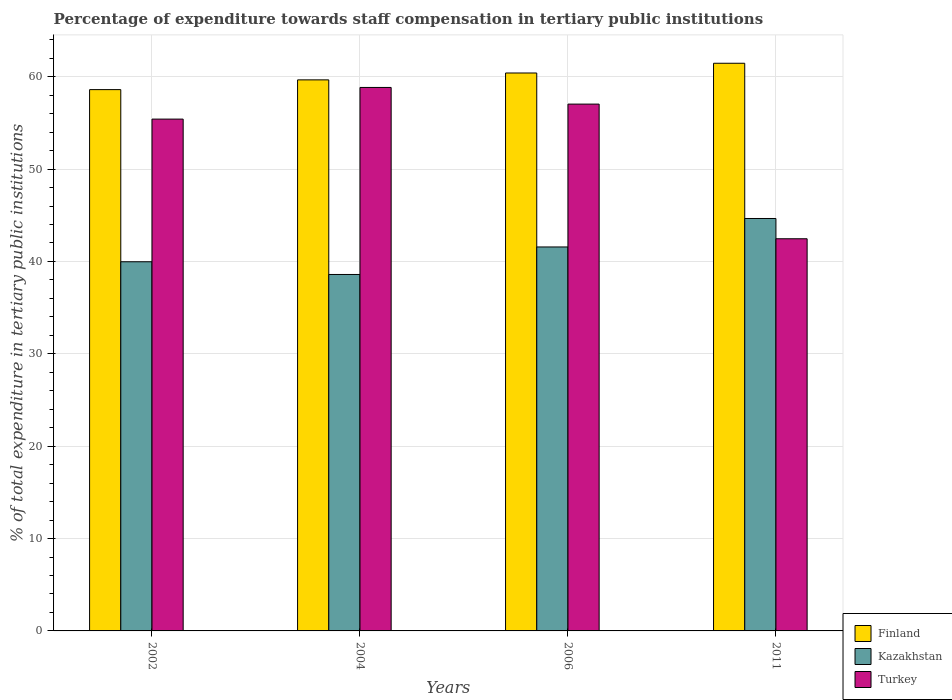Are the number of bars per tick equal to the number of legend labels?
Ensure brevity in your answer.  Yes. Are the number of bars on each tick of the X-axis equal?
Your answer should be compact. Yes. How many bars are there on the 2nd tick from the left?
Make the answer very short. 3. What is the label of the 1st group of bars from the left?
Ensure brevity in your answer.  2002. In how many cases, is the number of bars for a given year not equal to the number of legend labels?
Give a very brief answer. 0. What is the percentage of expenditure towards staff compensation in Finland in 2004?
Ensure brevity in your answer.  59.66. Across all years, what is the maximum percentage of expenditure towards staff compensation in Turkey?
Provide a short and direct response. 58.84. Across all years, what is the minimum percentage of expenditure towards staff compensation in Turkey?
Your answer should be compact. 42.45. In which year was the percentage of expenditure towards staff compensation in Finland maximum?
Your response must be concise. 2011. What is the total percentage of expenditure towards staff compensation in Finland in the graph?
Give a very brief answer. 240.11. What is the difference between the percentage of expenditure towards staff compensation in Turkey in 2002 and that in 2004?
Your answer should be very brief. -3.43. What is the difference between the percentage of expenditure towards staff compensation in Turkey in 2011 and the percentage of expenditure towards staff compensation in Finland in 2002?
Provide a succinct answer. -16.15. What is the average percentage of expenditure towards staff compensation in Kazakhstan per year?
Your answer should be very brief. 41.19. In the year 2002, what is the difference between the percentage of expenditure towards staff compensation in Kazakhstan and percentage of expenditure towards staff compensation in Turkey?
Offer a very short reply. -15.44. What is the ratio of the percentage of expenditure towards staff compensation in Finland in 2002 to that in 2004?
Keep it short and to the point. 0.98. Is the percentage of expenditure towards staff compensation in Turkey in 2002 less than that in 2004?
Give a very brief answer. Yes. Is the difference between the percentage of expenditure towards staff compensation in Kazakhstan in 2004 and 2011 greater than the difference between the percentage of expenditure towards staff compensation in Turkey in 2004 and 2011?
Provide a succinct answer. No. What is the difference between the highest and the second highest percentage of expenditure towards staff compensation in Finland?
Offer a terse response. 1.05. What is the difference between the highest and the lowest percentage of expenditure towards staff compensation in Kazakhstan?
Your response must be concise. 6.06. In how many years, is the percentage of expenditure towards staff compensation in Turkey greater than the average percentage of expenditure towards staff compensation in Turkey taken over all years?
Your answer should be compact. 3. Is the sum of the percentage of expenditure towards staff compensation in Turkey in 2006 and 2011 greater than the maximum percentage of expenditure towards staff compensation in Finland across all years?
Ensure brevity in your answer.  Yes. What does the 2nd bar from the left in 2011 represents?
Offer a very short reply. Kazakhstan. What does the 3rd bar from the right in 2002 represents?
Your answer should be compact. Finland. Are the values on the major ticks of Y-axis written in scientific E-notation?
Keep it short and to the point. No. Does the graph contain any zero values?
Ensure brevity in your answer.  No. Where does the legend appear in the graph?
Keep it short and to the point. Bottom right. How are the legend labels stacked?
Give a very brief answer. Vertical. What is the title of the graph?
Provide a succinct answer. Percentage of expenditure towards staff compensation in tertiary public institutions. Does "United States" appear as one of the legend labels in the graph?
Provide a succinct answer. No. What is the label or title of the Y-axis?
Keep it short and to the point. % of total expenditure in tertiary public institutions. What is the % of total expenditure in tertiary public institutions of Finland in 2002?
Your response must be concise. 58.6. What is the % of total expenditure in tertiary public institutions in Kazakhstan in 2002?
Ensure brevity in your answer.  39.97. What is the % of total expenditure in tertiary public institutions in Turkey in 2002?
Give a very brief answer. 55.41. What is the % of total expenditure in tertiary public institutions in Finland in 2004?
Your answer should be compact. 59.66. What is the % of total expenditure in tertiary public institutions of Kazakhstan in 2004?
Your response must be concise. 38.59. What is the % of total expenditure in tertiary public institutions of Turkey in 2004?
Provide a succinct answer. 58.84. What is the % of total expenditure in tertiary public institutions in Finland in 2006?
Your answer should be very brief. 60.4. What is the % of total expenditure in tertiary public institutions in Kazakhstan in 2006?
Provide a short and direct response. 41.57. What is the % of total expenditure in tertiary public institutions of Turkey in 2006?
Ensure brevity in your answer.  57.03. What is the % of total expenditure in tertiary public institutions of Finland in 2011?
Keep it short and to the point. 61.45. What is the % of total expenditure in tertiary public institutions in Kazakhstan in 2011?
Your answer should be very brief. 44.65. What is the % of total expenditure in tertiary public institutions of Turkey in 2011?
Ensure brevity in your answer.  42.45. Across all years, what is the maximum % of total expenditure in tertiary public institutions of Finland?
Keep it short and to the point. 61.45. Across all years, what is the maximum % of total expenditure in tertiary public institutions in Kazakhstan?
Your response must be concise. 44.65. Across all years, what is the maximum % of total expenditure in tertiary public institutions of Turkey?
Keep it short and to the point. 58.84. Across all years, what is the minimum % of total expenditure in tertiary public institutions in Finland?
Make the answer very short. 58.6. Across all years, what is the minimum % of total expenditure in tertiary public institutions in Kazakhstan?
Provide a succinct answer. 38.59. Across all years, what is the minimum % of total expenditure in tertiary public institutions in Turkey?
Keep it short and to the point. 42.45. What is the total % of total expenditure in tertiary public institutions of Finland in the graph?
Ensure brevity in your answer.  240.11. What is the total % of total expenditure in tertiary public institutions of Kazakhstan in the graph?
Offer a very short reply. 164.77. What is the total % of total expenditure in tertiary public institutions of Turkey in the graph?
Offer a terse response. 213.73. What is the difference between the % of total expenditure in tertiary public institutions in Finland in 2002 and that in 2004?
Make the answer very short. -1.06. What is the difference between the % of total expenditure in tertiary public institutions of Kazakhstan in 2002 and that in 2004?
Your answer should be very brief. 1.38. What is the difference between the % of total expenditure in tertiary public institutions in Turkey in 2002 and that in 2004?
Your response must be concise. -3.43. What is the difference between the % of total expenditure in tertiary public institutions of Finland in 2002 and that in 2006?
Your answer should be compact. -1.8. What is the difference between the % of total expenditure in tertiary public institutions in Kazakhstan in 2002 and that in 2006?
Your response must be concise. -1.6. What is the difference between the % of total expenditure in tertiary public institutions of Turkey in 2002 and that in 2006?
Keep it short and to the point. -1.63. What is the difference between the % of total expenditure in tertiary public institutions in Finland in 2002 and that in 2011?
Your answer should be very brief. -2.85. What is the difference between the % of total expenditure in tertiary public institutions of Kazakhstan in 2002 and that in 2011?
Give a very brief answer. -4.68. What is the difference between the % of total expenditure in tertiary public institutions of Turkey in 2002 and that in 2011?
Offer a terse response. 12.95. What is the difference between the % of total expenditure in tertiary public institutions of Finland in 2004 and that in 2006?
Your response must be concise. -0.74. What is the difference between the % of total expenditure in tertiary public institutions of Kazakhstan in 2004 and that in 2006?
Offer a terse response. -2.98. What is the difference between the % of total expenditure in tertiary public institutions of Turkey in 2004 and that in 2006?
Offer a very short reply. 1.8. What is the difference between the % of total expenditure in tertiary public institutions of Finland in 2004 and that in 2011?
Your answer should be compact. -1.8. What is the difference between the % of total expenditure in tertiary public institutions in Kazakhstan in 2004 and that in 2011?
Provide a succinct answer. -6.06. What is the difference between the % of total expenditure in tertiary public institutions in Turkey in 2004 and that in 2011?
Provide a succinct answer. 16.38. What is the difference between the % of total expenditure in tertiary public institutions in Finland in 2006 and that in 2011?
Offer a terse response. -1.05. What is the difference between the % of total expenditure in tertiary public institutions in Kazakhstan in 2006 and that in 2011?
Your response must be concise. -3.08. What is the difference between the % of total expenditure in tertiary public institutions of Turkey in 2006 and that in 2011?
Your response must be concise. 14.58. What is the difference between the % of total expenditure in tertiary public institutions in Finland in 2002 and the % of total expenditure in tertiary public institutions in Kazakhstan in 2004?
Your answer should be very brief. 20.01. What is the difference between the % of total expenditure in tertiary public institutions of Finland in 2002 and the % of total expenditure in tertiary public institutions of Turkey in 2004?
Offer a very short reply. -0.23. What is the difference between the % of total expenditure in tertiary public institutions of Kazakhstan in 2002 and the % of total expenditure in tertiary public institutions of Turkey in 2004?
Offer a terse response. -18.87. What is the difference between the % of total expenditure in tertiary public institutions in Finland in 2002 and the % of total expenditure in tertiary public institutions in Kazakhstan in 2006?
Keep it short and to the point. 17.03. What is the difference between the % of total expenditure in tertiary public institutions of Finland in 2002 and the % of total expenditure in tertiary public institutions of Turkey in 2006?
Your response must be concise. 1.57. What is the difference between the % of total expenditure in tertiary public institutions of Kazakhstan in 2002 and the % of total expenditure in tertiary public institutions of Turkey in 2006?
Give a very brief answer. -17.07. What is the difference between the % of total expenditure in tertiary public institutions of Finland in 2002 and the % of total expenditure in tertiary public institutions of Kazakhstan in 2011?
Offer a very short reply. 13.95. What is the difference between the % of total expenditure in tertiary public institutions of Finland in 2002 and the % of total expenditure in tertiary public institutions of Turkey in 2011?
Offer a terse response. 16.15. What is the difference between the % of total expenditure in tertiary public institutions of Kazakhstan in 2002 and the % of total expenditure in tertiary public institutions of Turkey in 2011?
Your answer should be very brief. -2.49. What is the difference between the % of total expenditure in tertiary public institutions of Finland in 2004 and the % of total expenditure in tertiary public institutions of Kazakhstan in 2006?
Ensure brevity in your answer.  18.09. What is the difference between the % of total expenditure in tertiary public institutions in Finland in 2004 and the % of total expenditure in tertiary public institutions in Turkey in 2006?
Offer a very short reply. 2.62. What is the difference between the % of total expenditure in tertiary public institutions of Kazakhstan in 2004 and the % of total expenditure in tertiary public institutions of Turkey in 2006?
Your response must be concise. -18.44. What is the difference between the % of total expenditure in tertiary public institutions in Finland in 2004 and the % of total expenditure in tertiary public institutions in Kazakhstan in 2011?
Your response must be concise. 15.01. What is the difference between the % of total expenditure in tertiary public institutions in Finland in 2004 and the % of total expenditure in tertiary public institutions in Turkey in 2011?
Give a very brief answer. 17.2. What is the difference between the % of total expenditure in tertiary public institutions of Kazakhstan in 2004 and the % of total expenditure in tertiary public institutions of Turkey in 2011?
Give a very brief answer. -3.87. What is the difference between the % of total expenditure in tertiary public institutions of Finland in 2006 and the % of total expenditure in tertiary public institutions of Kazakhstan in 2011?
Keep it short and to the point. 15.75. What is the difference between the % of total expenditure in tertiary public institutions of Finland in 2006 and the % of total expenditure in tertiary public institutions of Turkey in 2011?
Provide a succinct answer. 17.95. What is the difference between the % of total expenditure in tertiary public institutions of Kazakhstan in 2006 and the % of total expenditure in tertiary public institutions of Turkey in 2011?
Offer a very short reply. -0.89. What is the average % of total expenditure in tertiary public institutions of Finland per year?
Give a very brief answer. 60.03. What is the average % of total expenditure in tertiary public institutions of Kazakhstan per year?
Ensure brevity in your answer.  41.19. What is the average % of total expenditure in tertiary public institutions in Turkey per year?
Keep it short and to the point. 53.43. In the year 2002, what is the difference between the % of total expenditure in tertiary public institutions of Finland and % of total expenditure in tertiary public institutions of Kazakhstan?
Provide a short and direct response. 18.64. In the year 2002, what is the difference between the % of total expenditure in tertiary public institutions of Finland and % of total expenditure in tertiary public institutions of Turkey?
Offer a very short reply. 3.19. In the year 2002, what is the difference between the % of total expenditure in tertiary public institutions in Kazakhstan and % of total expenditure in tertiary public institutions in Turkey?
Make the answer very short. -15.44. In the year 2004, what is the difference between the % of total expenditure in tertiary public institutions in Finland and % of total expenditure in tertiary public institutions in Kazakhstan?
Offer a very short reply. 21.07. In the year 2004, what is the difference between the % of total expenditure in tertiary public institutions of Finland and % of total expenditure in tertiary public institutions of Turkey?
Provide a succinct answer. 0.82. In the year 2004, what is the difference between the % of total expenditure in tertiary public institutions in Kazakhstan and % of total expenditure in tertiary public institutions in Turkey?
Your answer should be compact. -20.25. In the year 2006, what is the difference between the % of total expenditure in tertiary public institutions in Finland and % of total expenditure in tertiary public institutions in Kazakhstan?
Keep it short and to the point. 18.83. In the year 2006, what is the difference between the % of total expenditure in tertiary public institutions of Finland and % of total expenditure in tertiary public institutions of Turkey?
Offer a terse response. 3.37. In the year 2006, what is the difference between the % of total expenditure in tertiary public institutions of Kazakhstan and % of total expenditure in tertiary public institutions of Turkey?
Keep it short and to the point. -15.47. In the year 2011, what is the difference between the % of total expenditure in tertiary public institutions of Finland and % of total expenditure in tertiary public institutions of Kazakhstan?
Give a very brief answer. 16.81. In the year 2011, what is the difference between the % of total expenditure in tertiary public institutions of Finland and % of total expenditure in tertiary public institutions of Turkey?
Make the answer very short. 19. In the year 2011, what is the difference between the % of total expenditure in tertiary public institutions of Kazakhstan and % of total expenditure in tertiary public institutions of Turkey?
Ensure brevity in your answer.  2.19. What is the ratio of the % of total expenditure in tertiary public institutions in Finland in 2002 to that in 2004?
Provide a succinct answer. 0.98. What is the ratio of the % of total expenditure in tertiary public institutions in Kazakhstan in 2002 to that in 2004?
Your response must be concise. 1.04. What is the ratio of the % of total expenditure in tertiary public institutions in Turkey in 2002 to that in 2004?
Keep it short and to the point. 0.94. What is the ratio of the % of total expenditure in tertiary public institutions of Finland in 2002 to that in 2006?
Ensure brevity in your answer.  0.97. What is the ratio of the % of total expenditure in tertiary public institutions of Kazakhstan in 2002 to that in 2006?
Your answer should be very brief. 0.96. What is the ratio of the % of total expenditure in tertiary public institutions of Turkey in 2002 to that in 2006?
Offer a terse response. 0.97. What is the ratio of the % of total expenditure in tertiary public institutions in Finland in 2002 to that in 2011?
Provide a succinct answer. 0.95. What is the ratio of the % of total expenditure in tertiary public institutions of Kazakhstan in 2002 to that in 2011?
Your response must be concise. 0.9. What is the ratio of the % of total expenditure in tertiary public institutions of Turkey in 2002 to that in 2011?
Ensure brevity in your answer.  1.31. What is the ratio of the % of total expenditure in tertiary public institutions of Kazakhstan in 2004 to that in 2006?
Offer a very short reply. 0.93. What is the ratio of the % of total expenditure in tertiary public institutions in Turkey in 2004 to that in 2006?
Provide a succinct answer. 1.03. What is the ratio of the % of total expenditure in tertiary public institutions in Finland in 2004 to that in 2011?
Ensure brevity in your answer.  0.97. What is the ratio of the % of total expenditure in tertiary public institutions of Kazakhstan in 2004 to that in 2011?
Your answer should be very brief. 0.86. What is the ratio of the % of total expenditure in tertiary public institutions in Turkey in 2004 to that in 2011?
Give a very brief answer. 1.39. What is the ratio of the % of total expenditure in tertiary public institutions of Finland in 2006 to that in 2011?
Your answer should be compact. 0.98. What is the ratio of the % of total expenditure in tertiary public institutions of Turkey in 2006 to that in 2011?
Provide a succinct answer. 1.34. What is the difference between the highest and the second highest % of total expenditure in tertiary public institutions of Finland?
Your answer should be very brief. 1.05. What is the difference between the highest and the second highest % of total expenditure in tertiary public institutions in Kazakhstan?
Make the answer very short. 3.08. What is the difference between the highest and the second highest % of total expenditure in tertiary public institutions in Turkey?
Keep it short and to the point. 1.8. What is the difference between the highest and the lowest % of total expenditure in tertiary public institutions of Finland?
Your answer should be very brief. 2.85. What is the difference between the highest and the lowest % of total expenditure in tertiary public institutions of Kazakhstan?
Your answer should be very brief. 6.06. What is the difference between the highest and the lowest % of total expenditure in tertiary public institutions of Turkey?
Offer a very short reply. 16.38. 